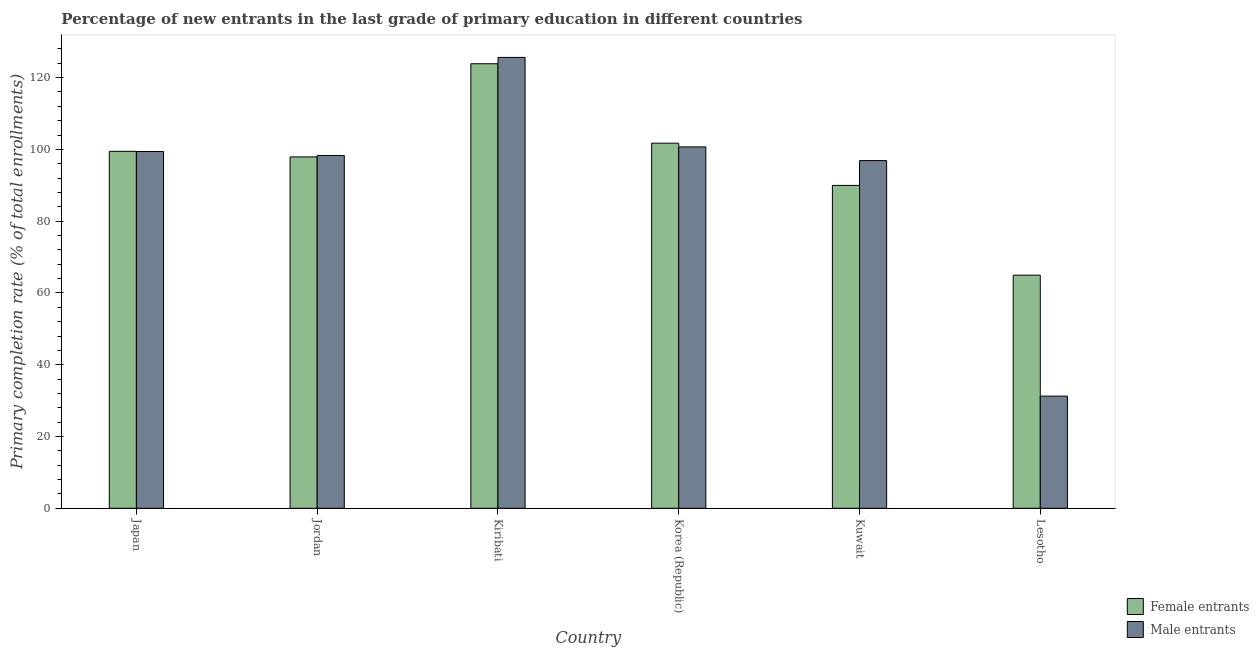How many different coloured bars are there?
Provide a succinct answer. 2. Are the number of bars per tick equal to the number of legend labels?
Provide a short and direct response. Yes. How many bars are there on the 2nd tick from the left?
Keep it short and to the point. 2. What is the label of the 2nd group of bars from the left?
Make the answer very short. Jordan. What is the primary completion rate of male entrants in Kiribati?
Provide a succinct answer. 125.63. Across all countries, what is the maximum primary completion rate of male entrants?
Offer a very short reply. 125.63. Across all countries, what is the minimum primary completion rate of male entrants?
Provide a short and direct response. 31.26. In which country was the primary completion rate of male entrants maximum?
Your response must be concise. Kiribati. In which country was the primary completion rate of male entrants minimum?
Keep it short and to the point. Lesotho. What is the total primary completion rate of female entrants in the graph?
Offer a terse response. 577.89. What is the difference between the primary completion rate of male entrants in Korea (Republic) and that in Lesotho?
Keep it short and to the point. 69.44. What is the difference between the primary completion rate of female entrants in Korea (Republic) and the primary completion rate of male entrants in Kuwait?
Make the answer very short. 4.85. What is the average primary completion rate of male entrants per country?
Keep it short and to the point. 92.03. What is the difference between the primary completion rate of male entrants and primary completion rate of female entrants in Korea (Republic)?
Keep it short and to the point. -1.04. In how many countries, is the primary completion rate of male entrants greater than 40 %?
Make the answer very short. 5. What is the ratio of the primary completion rate of female entrants in Japan to that in Kiribati?
Your answer should be very brief. 0.8. Is the difference between the primary completion rate of male entrants in Kuwait and Lesotho greater than the difference between the primary completion rate of female entrants in Kuwait and Lesotho?
Provide a short and direct response. Yes. What is the difference between the highest and the second highest primary completion rate of male entrants?
Ensure brevity in your answer.  24.93. What is the difference between the highest and the lowest primary completion rate of female entrants?
Give a very brief answer. 58.91. In how many countries, is the primary completion rate of female entrants greater than the average primary completion rate of female entrants taken over all countries?
Keep it short and to the point. 4. What does the 1st bar from the left in Japan represents?
Your response must be concise. Female entrants. What does the 2nd bar from the right in Korea (Republic) represents?
Your answer should be very brief. Female entrants. How many countries are there in the graph?
Make the answer very short. 6. Does the graph contain any zero values?
Offer a very short reply. No. How many legend labels are there?
Keep it short and to the point. 2. What is the title of the graph?
Make the answer very short. Percentage of new entrants in the last grade of primary education in different countries. What is the label or title of the Y-axis?
Give a very brief answer. Primary completion rate (% of total enrollments). What is the Primary completion rate (% of total enrollments) in Female entrants in Japan?
Your answer should be compact. 99.46. What is the Primary completion rate (% of total enrollments) in Male entrants in Japan?
Ensure brevity in your answer.  99.41. What is the Primary completion rate (% of total enrollments) in Female entrants in Jordan?
Offer a very short reply. 97.91. What is the Primary completion rate (% of total enrollments) in Male entrants in Jordan?
Provide a short and direct response. 98.31. What is the Primary completion rate (% of total enrollments) in Female entrants in Kiribati?
Offer a very short reply. 123.87. What is the Primary completion rate (% of total enrollments) of Male entrants in Kiribati?
Offer a very short reply. 125.63. What is the Primary completion rate (% of total enrollments) in Female entrants in Korea (Republic)?
Offer a very short reply. 101.73. What is the Primary completion rate (% of total enrollments) of Male entrants in Korea (Republic)?
Give a very brief answer. 100.7. What is the Primary completion rate (% of total enrollments) in Female entrants in Kuwait?
Give a very brief answer. 89.96. What is the Primary completion rate (% of total enrollments) in Male entrants in Kuwait?
Offer a very short reply. 96.88. What is the Primary completion rate (% of total enrollments) of Female entrants in Lesotho?
Provide a short and direct response. 64.96. What is the Primary completion rate (% of total enrollments) in Male entrants in Lesotho?
Keep it short and to the point. 31.26. Across all countries, what is the maximum Primary completion rate (% of total enrollments) of Female entrants?
Give a very brief answer. 123.87. Across all countries, what is the maximum Primary completion rate (% of total enrollments) of Male entrants?
Your response must be concise. 125.63. Across all countries, what is the minimum Primary completion rate (% of total enrollments) of Female entrants?
Make the answer very short. 64.96. Across all countries, what is the minimum Primary completion rate (% of total enrollments) of Male entrants?
Offer a terse response. 31.26. What is the total Primary completion rate (% of total enrollments) of Female entrants in the graph?
Your answer should be compact. 577.89. What is the total Primary completion rate (% of total enrollments) in Male entrants in the graph?
Offer a terse response. 552.18. What is the difference between the Primary completion rate (% of total enrollments) of Female entrants in Japan and that in Jordan?
Your answer should be very brief. 1.55. What is the difference between the Primary completion rate (% of total enrollments) of Male entrants in Japan and that in Jordan?
Make the answer very short. 1.1. What is the difference between the Primary completion rate (% of total enrollments) in Female entrants in Japan and that in Kiribati?
Give a very brief answer. -24.41. What is the difference between the Primary completion rate (% of total enrollments) of Male entrants in Japan and that in Kiribati?
Offer a very short reply. -26.22. What is the difference between the Primary completion rate (% of total enrollments) of Female entrants in Japan and that in Korea (Republic)?
Keep it short and to the point. -2.27. What is the difference between the Primary completion rate (% of total enrollments) of Male entrants in Japan and that in Korea (Republic)?
Offer a very short reply. -1.29. What is the difference between the Primary completion rate (% of total enrollments) of Female entrants in Japan and that in Kuwait?
Give a very brief answer. 9.5. What is the difference between the Primary completion rate (% of total enrollments) in Male entrants in Japan and that in Kuwait?
Your answer should be compact. 2.53. What is the difference between the Primary completion rate (% of total enrollments) in Female entrants in Japan and that in Lesotho?
Your answer should be very brief. 34.51. What is the difference between the Primary completion rate (% of total enrollments) in Male entrants in Japan and that in Lesotho?
Provide a succinct answer. 68.15. What is the difference between the Primary completion rate (% of total enrollments) in Female entrants in Jordan and that in Kiribati?
Give a very brief answer. -25.96. What is the difference between the Primary completion rate (% of total enrollments) in Male entrants in Jordan and that in Kiribati?
Your answer should be compact. -27.32. What is the difference between the Primary completion rate (% of total enrollments) of Female entrants in Jordan and that in Korea (Republic)?
Offer a very short reply. -3.83. What is the difference between the Primary completion rate (% of total enrollments) of Male entrants in Jordan and that in Korea (Republic)?
Make the answer very short. -2.39. What is the difference between the Primary completion rate (% of total enrollments) in Female entrants in Jordan and that in Kuwait?
Your response must be concise. 7.94. What is the difference between the Primary completion rate (% of total enrollments) in Male entrants in Jordan and that in Kuwait?
Give a very brief answer. 1.43. What is the difference between the Primary completion rate (% of total enrollments) of Female entrants in Jordan and that in Lesotho?
Offer a terse response. 32.95. What is the difference between the Primary completion rate (% of total enrollments) in Male entrants in Jordan and that in Lesotho?
Your response must be concise. 67.05. What is the difference between the Primary completion rate (% of total enrollments) in Female entrants in Kiribati and that in Korea (Republic)?
Provide a short and direct response. 22.14. What is the difference between the Primary completion rate (% of total enrollments) in Male entrants in Kiribati and that in Korea (Republic)?
Ensure brevity in your answer.  24.93. What is the difference between the Primary completion rate (% of total enrollments) of Female entrants in Kiribati and that in Kuwait?
Keep it short and to the point. 33.91. What is the difference between the Primary completion rate (% of total enrollments) of Male entrants in Kiribati and that in Kuwait?
Ensure brevity in your answer.  28.75. What is the difference between the Primary completion rate (% of total enrollments) of Female entrants in Kiribati and that in Lesotho?
Provide a succinct answer. 58.91. What is the difference between the Primary completion rate (% of total enrollments) in Male entrants in Kiribati and that in Lesotho?
Provide a succinct answer. 94.37. What is the difference between the Primary completion rate (% of total enrollments) of Female entrants in Korea (Republic) and that in Kuwait?
Your response must be concise. 11.77. What is the difference between the Primary completion rate (% of total enrollments) in Male entrants in Korea (Republic) and that in Kuwait?
Offer a terse response. 3.82. What is the difference between the Primary completion rate (% of total enrollments) in Female entrants in Korea (Republic) and that in Lesotho?
Offer a very short reply. 36.78. What is the difference between the Primary completion rate (% of total enrollments) of Male entrants in Korea (Republic) and that in Lesotho?
Your answer should be very brief. 69.44. What is the difference between the Primary completion rate (% of total enrollments) in Female entrants in Kuwait and that in Lesotho?
Provide a succinct answer. 25.01. What is the difference between the Primary completion rate (% of total enrollments) in Male entrants in Kuwait and that in Lesotho?
Your response must be concise. 65.62. What is the difference between the Primary completion rate (% of total enrollments) of Female entrants in Japan and the Primary completion rate (% of total enrollments) of Male entrants in Jordan?
Offer a terse response. 1.15. What is the difference between the Primary completion rate (% of total enrollments) of Female entrants in Japan and the Primary completion rate (% of total enrollments) of Male entrants in Kiribati?
Your response must be concise. -26.17. What is the difference between the Primary completion rate (% of total enrollments) of Female entrants in Japan and the Primary completion rate (% of total enrollments) of Male entrants in Korea (Republic)?
Your answer should be very brief. -1.24. What is the difference between the Primary completion rate (% of total enrollments) in Female entrants in Japan and the Primary completion rate (% of total enrollments) in Male entrants in Kuwait?
Provide a short and direct response. 2.58. What is the difference between the Primary completion rate (% of total enrollments) in Female entrants in Japan and the Primary completion rate (% of total enrollments) in Male entrants in Lesotho?
Your response must be concise. 68.2. What is the difference between the Primary completion rate (% of total enrollments) in Female entrants in Jordan and the Primary completion rate (% of total enrollments) in Male entrants in Kiribati?
Your answer should be very brief. -27.72. What is the difference between the Primary completion rate (% of total enrollments) of Female entrants in Jordan and the Primary completion rate (% of total enrollments) of Male entrants in Korea (Republic)?
Offer a very short reply. -2.79. What is the difference between the Primary completion rate (% of total enrollments) of Female entrants in Jordan and the Primary completion rate (% of total enrollments) of Male entrants in Kuwait?
Your response must be concise. 1.02. What is the difference between the Primary completion rate (% of total enrollments) of Female entrants in Jordan and the Primary completion rate (% of total enrollments) of Male entrants in Lesotho?
Provide a short and direct response. 66.65. What is the difference between the Primary completion rate (% of total enrollments) of Female entrants in Kiribati and the Primary completion rate (% of total enrollments) of Male entrants in Korea (Republic)?
Offer a very short reply. 23.17. What is the difference between the Primary completion rate (% of total enrollments) of Female entrants in Kiribati and the Primary completion rate (% of total enrollments) of Male entrants in Kuwait?
Keep it short and to the point. 26.99. What is the difference between the Primary completion rate (% of total enrollments) of Female entrants in Kiribati and the Primary completion rate (% of total enrollments) of Male entrants in Lesotho?
Make the answer very short. 92.61. What is the difference between the Primary completion rate (% of total enrollments) of Female entrants in Korea (Republic) and the Primary completion rate (% of total enrollments) of Male entrants in Kuwait?
Provide a short and direct response. 4.85. What is the difference between the Primary completion rate (% of total enrollments) of Female entrants in Korea (Republic) and the Primary completion rate (% of total enrollments) of Male entrants in Lesotho?
Your answer should be very brief. 70.48. What is the difference between the Primary completion rate (% of total enrollments) of Female entrants in Kuwait and the Primary completion rate (% of total enrollments) of Male entrants in Lesotho?
Your response must be concise. 58.71. What is the average Primary completion rate (% of total enrollments) in Female entrants per country?
Keep it short and to the point. 96.32. What is the average Primary completion rate (% of total enrollments) in Male entrants per country?
Provide a succinct answer. 92.03. What is the difference between the Primary completion rate (% of total enrollments) in Female entrants and Primary completion rate (% of total enrollments) in Male entrants in Japan?
Offer a very short reply. 0.05. What is the difference between the Primary completion rate (% of total enrollments) of Female entrants and Primary completion rate (% of total enrollments) of Male entrants in Jordan?
Your answer should be compact. -0.4. What is the difference between the Primary completion rate (% of total enrollments) in Female entrants and Primary completion rate (% of total enrollments) in Male entrants in Kiribati?
Provide a short and direct response. -1.76. What is the difference between the Primary completion rate (% of total enrollments) in Female entrants and Primary completion rate (% of total enrollments) in Male entrants in Korea (Republic)?
Your response must be concise. 1.04. What is the difference between the Primary completion rate (% of total enrollments) in Female entrants and Primary completion rate (% of total enrollments) in Male entrants in Kuwait?
Provide a short and direct response. -6.92. What is the difference between the Primary completion rate (% of total enrollments) of Female entrants and Primary completion rate (% of total enrollments) of Male entrants in Lesotho?
Give a very brief answer. 33.7. What is the ratio of the Primary completion rate (% of total enrollments) in Female entrants in Japan to that in Jordan?
Offer a very short reply. 1.02. What is the ratio of the Primary completion rate (% of total enrollments) of Male entrants in Japan to that in Jordan?
Provide a short and direct response. 1.01. What is the ratio of the Primary completion rate (% of total enrollments) of Female entrants in Japan to that in Kiribati?
Keep it short and to the point. 0.8. What is the ratio of the Primary completion rate (% of total enrollments) of Male entrants in Japan to that in Kiribati?
Your answer should be compact. 0.79. What is the ratio of the Primary completion rate (% of total enrollments) of Female entrants in Japan to that in Korea (Republic)?
Your answer should be compact. 0.98. What is the ratio of the Primary completion rate (% of total enrollments) of Male entrants in Japan to that in Korea (Republic)?
Your answer should be very brief. 0.99. What is the ratio of the Primary completion rate (% of total enrollments) of Female entrants in Japan to that in Kuwait?
Provide a short and direct response. 1.11. What is the ratio of the Primary completion rate (% of total enrollments) of Male entrants in Japan to that in Kuwait?
Your response must be concise. 1.03. What is the ratio of the Primary completion rate (% of total enrollments) in Female entrants in Japan to that in Lesotho?
Provide a short and direct response. 1.53. What is the ratio of the Primary completion rate (% of total enrollments) of Male entrants in Japan to that in Lesotho?
Give a very brief answer. 3.18. What is the ratio of the Primary completion rate (% of total enrollments) in Female entrants in Jordan to that in Kiribati?
Make the answer very short. 0.79. What is the ratio of the Primary completion rate (% of total enrollments) in Male entrants in Jordan to that in Kiribati?
Provide a succinct answer. 0.78. What is the ratio of the Primary completion rate (% of total enrollments) in Female entrants in Jordan to that in Korea (Republic)?
Your answer should be compact. 0.96. What is the ratio of the Primary completion rate (% of total enrollments) of Male entrants in Jordan to that in Korea (Republic)?
Ensure brevity in your answer.  0.98. What is the ratio of the Primary completion rate (% of total enrollments) in Female entrants in Jordan to that in Kuwait?
Make the answer very short. 1.09. What is the ratio of the Primary completion rate (% of total enrollments) in Male entrants in Jordan to that in Kuwait?
Your answer should be compact. 1.01. What is the ratio of the Primary completion rate (% of total enrollments) of Female entrants in Jordan to that in Lesotho?
Provide a succinct answer. 1.51. What is the ratio of the Primary completion rate (% of total enrollments) of Male entrants in Jordan to that in Lesotho?
Provide a short and direct response. 3.15. What is the ratio of the Primary completion rate (% of total enrollments) in Female entrants in Kiribati to that in Korea (Republic)?
Offer a very short reply. 1.22. What is the ratio of the Primary completion rate (% of total enrollments) of Male entrants in Kiribati to that in Korea (Republic)?
Your answer should be compact. 1.25. What is the ratio of the Primary completion rate (% of total enrollments) in Female entrants in Kiribati to that in Kuwait?
Your answer should be very brief. 1.38. What is the ratio of the Primary completion rate (% of total enrollments) of Male entrants in Kiribati to that in Kuwait?
Give a very brief answer. 1.3. What is the ratio of the Primary completion rate (% of total enrollments) in Female entrants in Kiribati to that in Lesotho?
Provide a succinct answer. 1.91. What is the ratio of the Primary completion rate (% of total enrollments) in Male entrants in Kiribati to that in Lesotho?
Keep it short and to the point. 4.02. What is the ratio of the Primary completion rate (% of total enrollments) in Female entrants in Korea (Republic) to that in Kuwait?
Your answer should be very brief. 1.13. What is the ratio of the Primary completion rate (% of total enrollments) of Male entrants in Korea (Republic) to that in Kuwait?
Provide a short and direct response. 1.04. What is the ratio of the Primary completion rate (% of total enrollments) of Female entrants in Korea (Republic) to that in Lesotho?
Provide a short and direct response. 1.57. What is the ratio of the Primary completion rate (% of total enrollments) of Male entrants in Korea (Republic) to that in Lesotho?
Offer a very short reply. 3.22. What is the ratio of the Primary completion rate (% of total enrollments) in Female entrants in Kuwait to that in Lesotho?
Give a very brief answer. 1.39. What is the ratio of the Primary completion rate (% of total enrollments) of Male entrants in Kuwait to that in Lesotho?
Your answer should be compact. 3.1. What is the difference between the highest and the second highest Primary completion rate (% of total enrollments) of Female entrants?
Your response must be concise. 22.14. What is the difference between the highest and the second highest Primary completion rate (% of total enrollments) of Male entrants?
Your answer should be very brief. 24.93. What is the difference between the highest and the lowest Primary completion rate (% of total enrollments) of Female entrants?
Provide a succinct answer. 58.91. What is the difference between the highest and the lowest Primary completion rate (% of total enrollments) in Male entrants?
Your response must be concise. 94.37. 